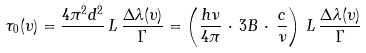<formula> <loc_0><loc_0><loc_500><loc_500>\tau _ { 0 } ( \upsilon ) = \frac { 4 \pi ^ { 2 } d ^ { 2 } } { } \, L \, \frac { \Delta \lambda ( \upsilon ) } { \Gamma } = \left ( \frac { h \nu } { 4 \pi } \, \cdot \, 3 B \, \cdot \, \frac { c } { \nu } \right ) \, L \, \frac { \Delta \lambda ( \upsilon ) } { \Gamma }</formula> 